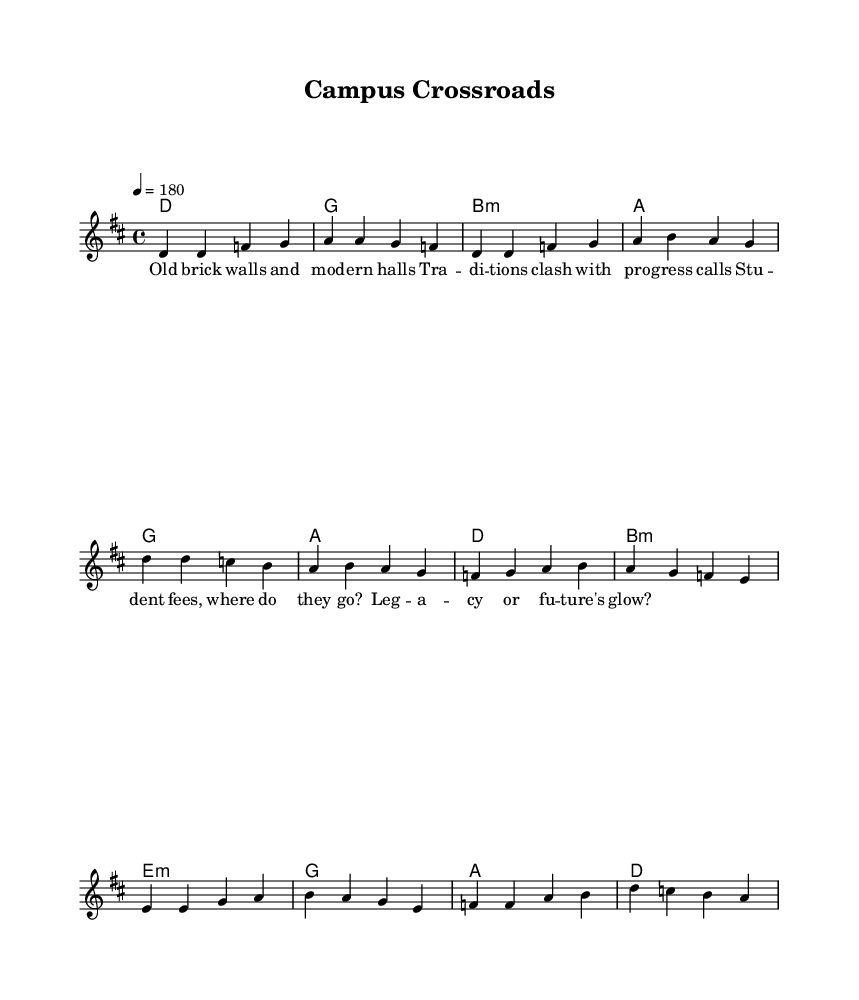What is the key signature of this music? The key signature can be determined from the global section of the code where it is set to D major, which has two sharps (F# and C#).
Answer: D major What is the time signature of this piece? The time signature is indicated in the global section where it is defined as 4/4, meaning there are four beats in each measure.
Answer: 4/4 What is the tempo marking for this music? The tempo is specified in the global section, where it states "4 = 180," indicating the speed at which the piece should be played, measured in beats per minute.
Answer: 180 How many measures are there in the verse? Counting the measures in the melody section, there are a total of four measures defined for the verse part.
Answer: 4 What is the structure of the lyrics in the music? The lyrics are divided into sections corresponding to the music: "Verse," "Chorus," and "Bridge." This indicates there are distinct segments to the song that align with typical song structure in punk and melodic styles.
Answer: Verse, Chorus, Bridge What type of harmony is used during the verse? The harmony for the verse consists of the chords defined in the chordmode section, which includes D, G, B minor, and A chords. This combination supports the melody and captures the emotional essence of punk rock.
Answer: D, G, B minor, A 